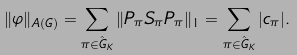<formula> <loc_0><loc_0><loc_500><loc_500>\| \varphi \| _ { A ( G ) } = \sum _ { \pi \in \hat { G } _ { K } } \| P _ { \pi } S _ { \pi } P _ { \pi } \| _ { 1 } = \sum _ { \pi \in \hat { G } _ { K } } | c _ { \pi } | .</formula> 